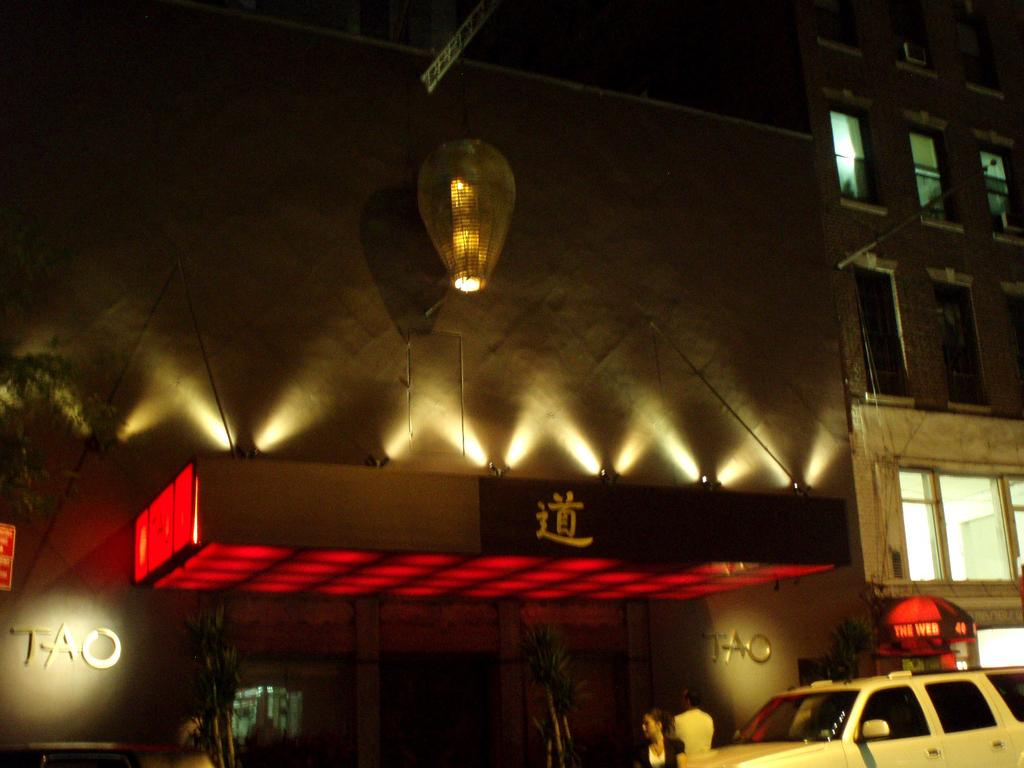Provide a one-sentence caption for the provided image. The front of a building that has the word TAO on the wall. 